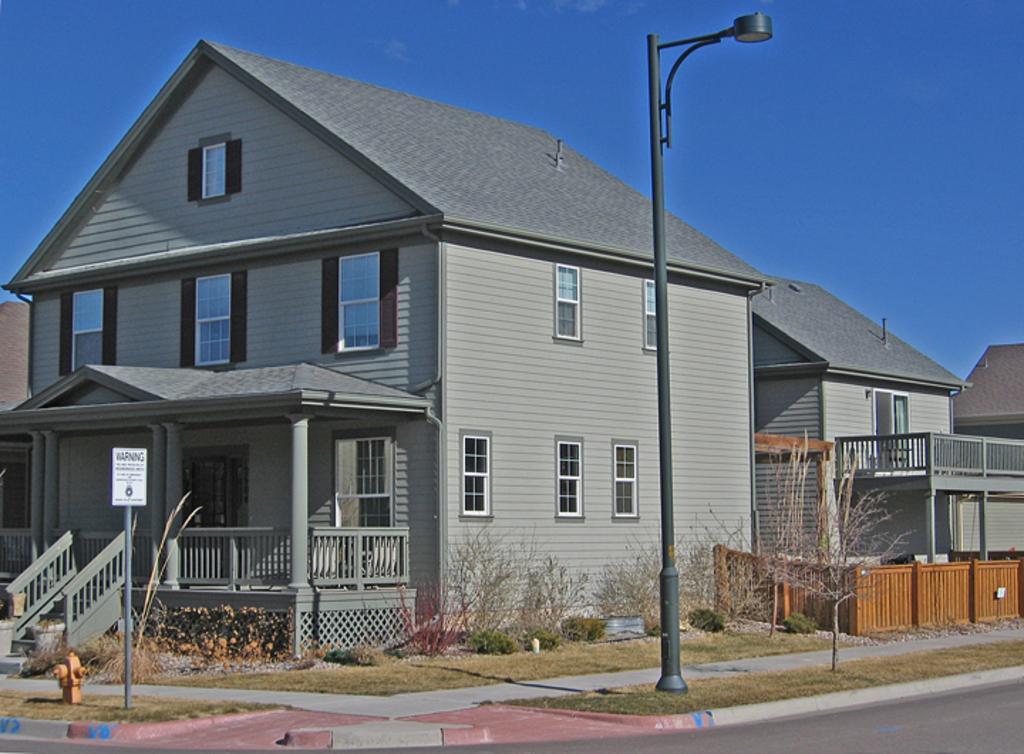Could you give a brief overview of what you see in this image? In this picture we can see the road, grass, plants, fences, pillars, buildings with windows, signboard, street lamp, poles, hydrant and in the background we can see the sky. 